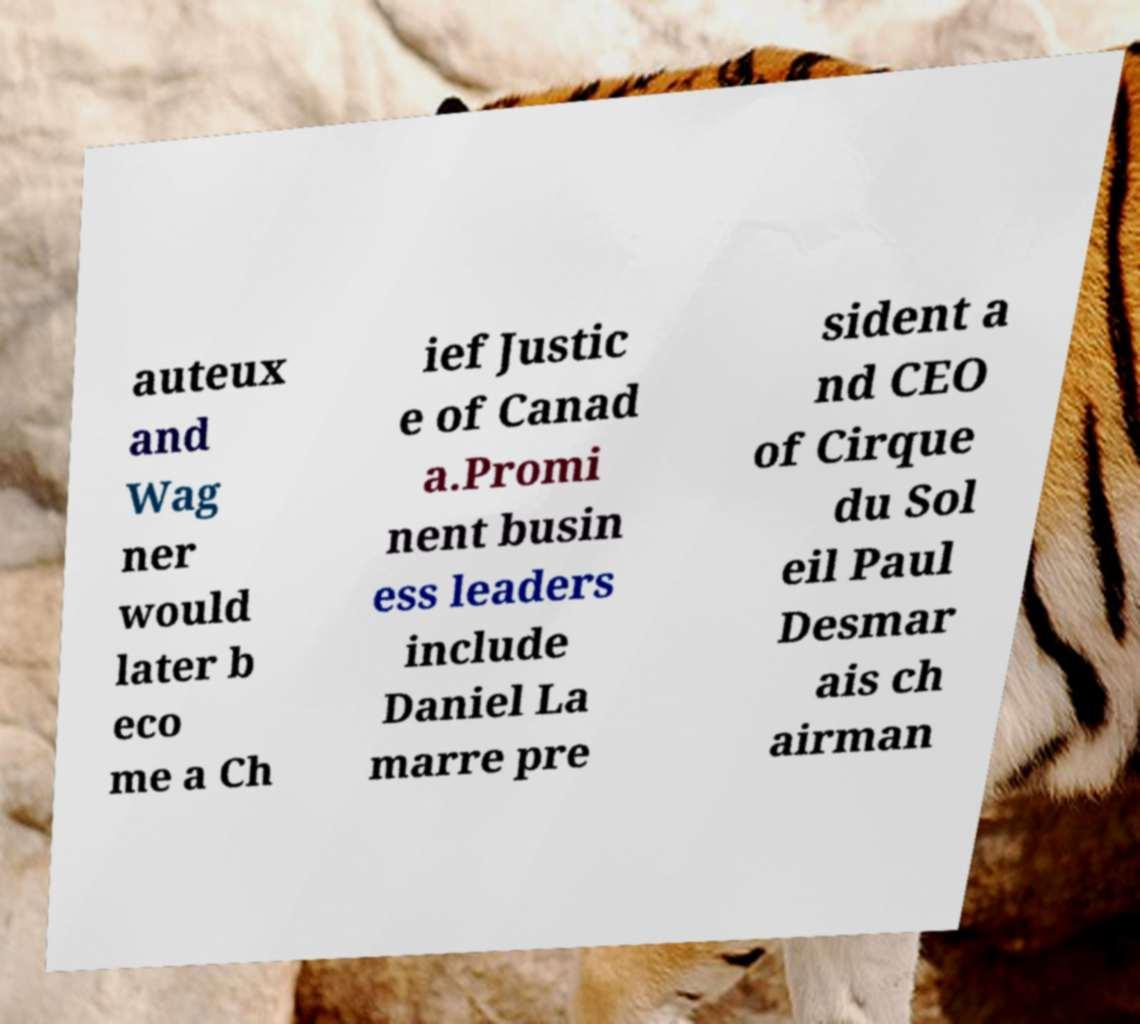Please identify and transcribe the text found in this image. auteux and Wag ner would later b eco me a Ch ief Justic e of Canad a.Promi nent busin ess leaders include Daniel La marre pre sident a nd CEO of Cirque du Sol eil Paul Desmar ais ch airman 